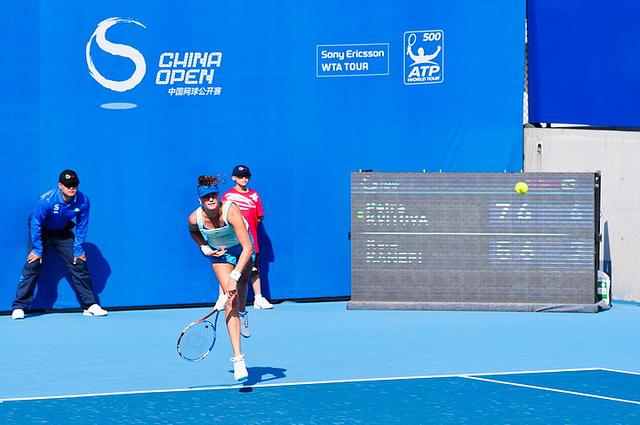What country did this take place in?
Give a very brief answer. China. Is someone wearing a blue visor?
Write a very short answer. Yes. Is the tennis ball next to the scoreboard?
Answer briefly. No. 